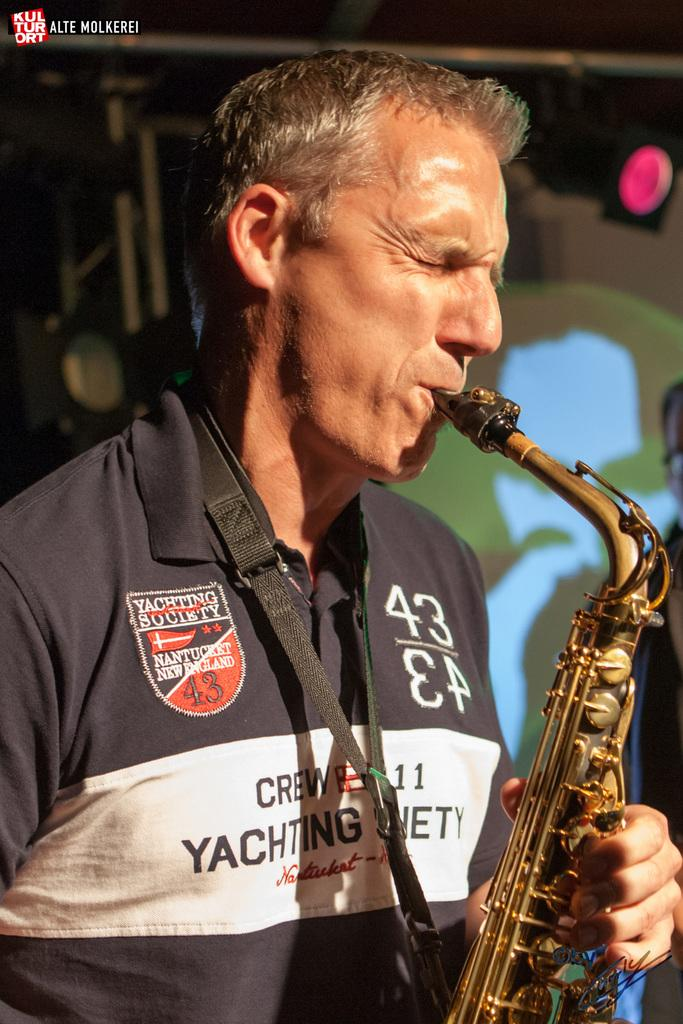What is the person in the image doing? The person is playing a musical instrument. What can be seen in the background of the image? There are poles, a light, and a wall in the background of the image. Where is the market located in the image? There is no market present in the image. How does the wind affect the person playing the musical instrument in the image? The image does not show any wind, and therefore it cannot affect the person playing the musical instrument. 